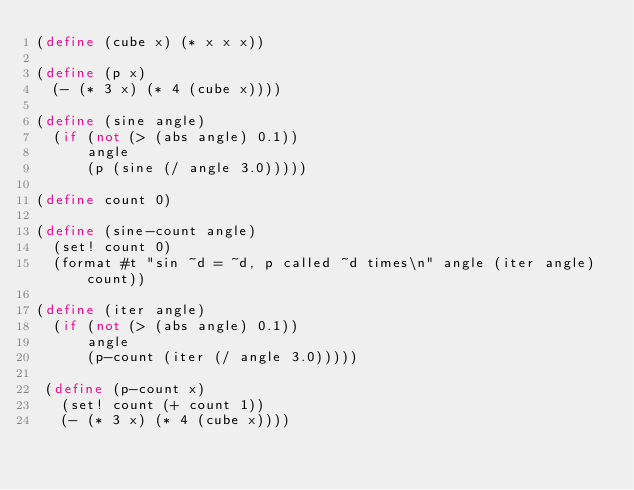<code> <loc_0><loc_0><loc_500><loc_500><_Scheme_>(define (cube x) (* x x x))

(define (p x) 
  (- (* 3 x) (* 4 (cube x))))

(define (sine angle)
  (if (not (> (abs angle) 0.1))
      angle
      (p (sine (/ angle 3.0)))))

(define count 0)

(define (sine-count angle)
  (set! count 0)
  (format #t "sin ~d = ~d, p called ~d times\n" angle (iter angle) count))

(define (iter angle)
  (if (not (> (abs angle) 0.1))
      angle
      (p-count (iter (/ angle 3.0)))))

 (define (p-count x)
   (set! count (+ count 1))
   (- (* 3 x) (* 4 (cube x))))

   
</code> 